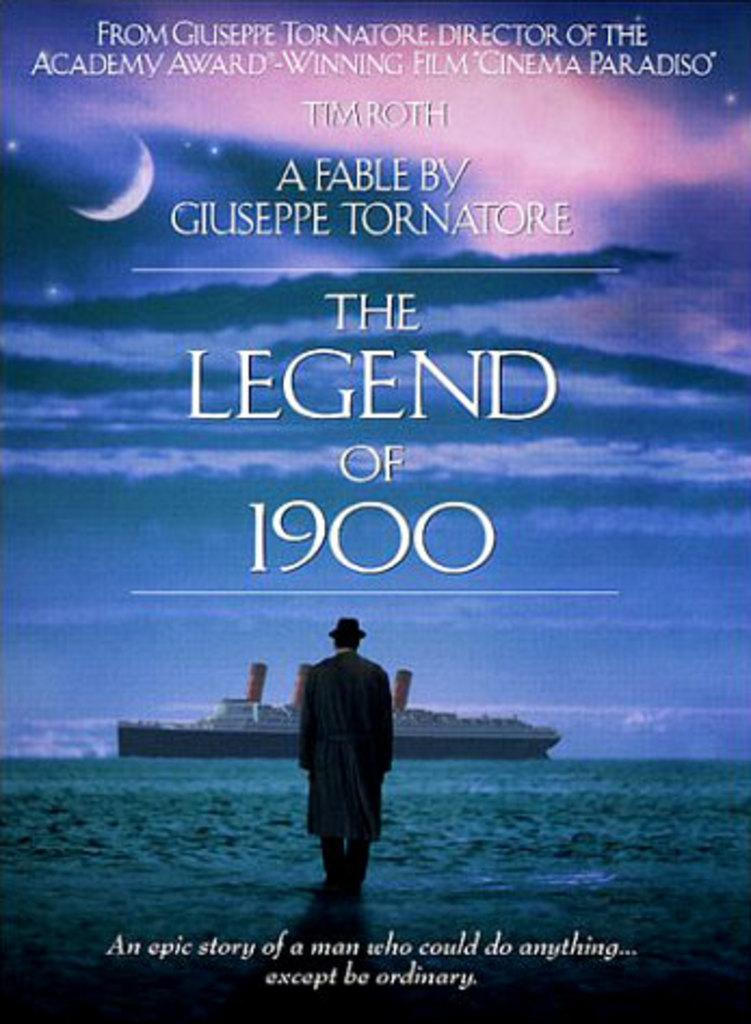<image>
Summarize the visual content of the image. The Legend of 1900 poster has a scene of a boat on the ocean. 